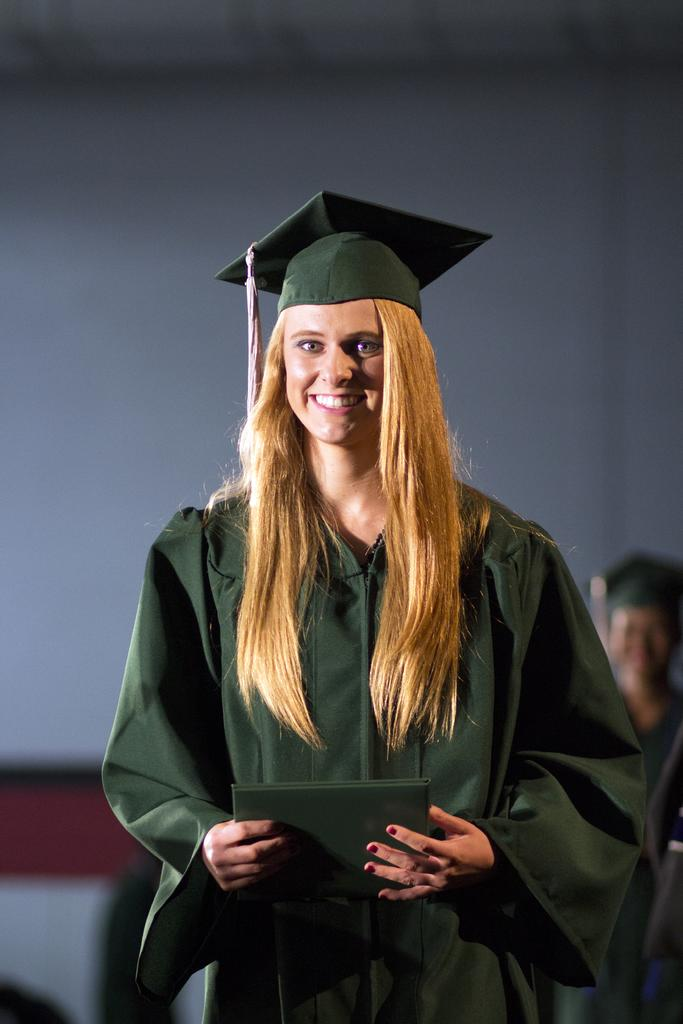What is the main subject of the image? The main subject of the image is a woman. What is the woman wearing in the image? The woman is wearing an academic dress. What is the woman holding in the image? The woman is holding a book. Can you see any giants walking along the river in the image? There is no river or giants present in the image; it features a woman wearing an academic dress and holding a book. 